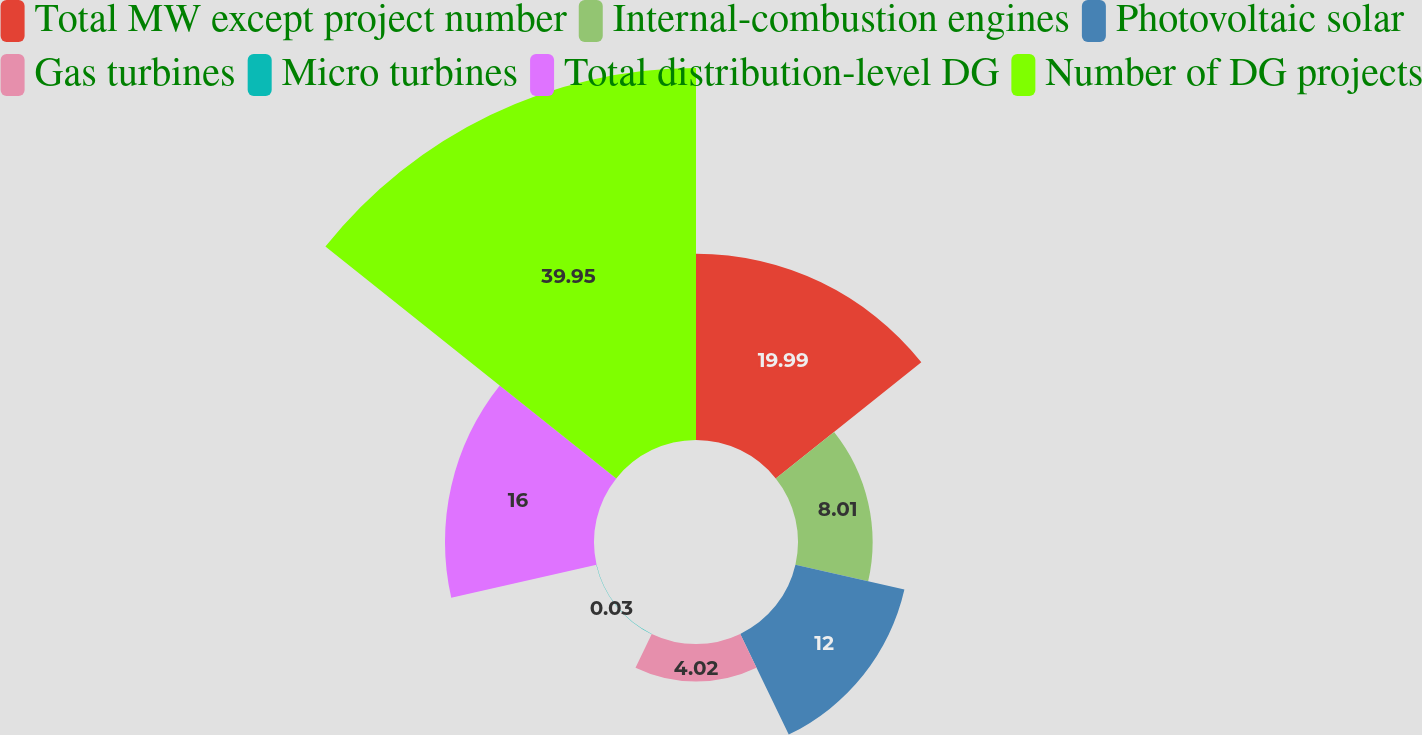Convert chart to OTSL. <chart><loc_0><loc_0><loc_500><loc_500><pie_chart><fcel>Total MW except project number<fcel>Internal-combustion engines<fcel>Photovoltaic solar<fcel>Gas turbines<fcel>Micro turbines<fcel>Total distribution-level DG<fcel>Number of DG projects<nl><fcel>19.99%<fcel>8.01%<fcel>12.0%<fcel>4.02%<fcel>0.03%<fcel>16.0%<fcel>39.94%<nl></chart> 